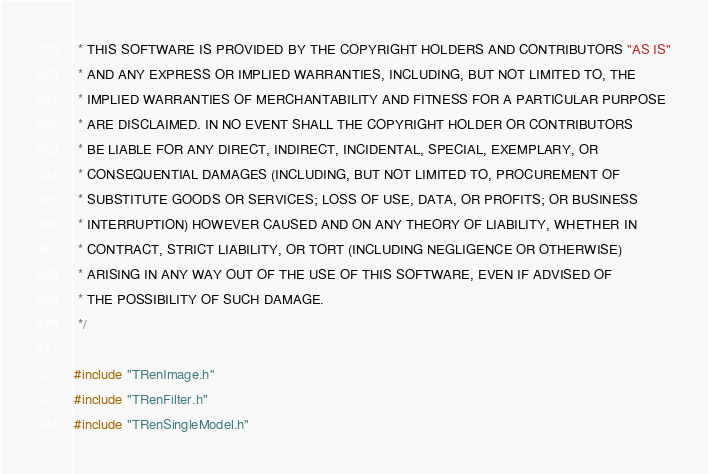<code> <loc_0><loc_0><loc_500><loc_500><_C++_> * THIS SOFTWARE IS PROVIDED BY THE COPYRIGHT HOLDERS AND CONTRIBUTORS "AS IS"
 * AND ANY EXPRESS OR IMPLIED WARRANTIES, INCLUDING, BUT NOT LIMITED TO, THE
 * IMPLIED WARRANTIES OF MERCHANTABILITY AND FITNESS FOR A PARTICULAR PURPOSE
 * ARE DISCLAIMED. IN NO EVENT SHALL THE COPYRIGHT HOLDER OR CONTRIBUTORS
 * BE LIABLE FOR ANY DIRECT, INDIRECT, INCIDENTAL, SPECIAL, EXEMPLARY, OR
 * CONSEQUENTIAL DAMAGES (INCLUDING, BUT NOT LIMITED TO, PROCUREMENT OF
 * SUBSTITUTE GOODS OR SERVICES; LOSS OF USE, DATA, OR PROFITS; OR BUSINESS
 * INTERRUPTION) HOWEVER CAUSED AND ON ANY THEORY OF LIABILITY, WHETHER IN
 * CONTRACT, STRICT LIABILITY, OR TORT (INCLUDING NEGLIGENCE OR OTHERWISE)
 * ARISING IN ANY WAY OUT OF THE USE OF THIS SOFTWARE, EVEN IF ADVISED OF
 * THE POSSIBILITY OF SUCH DAMAGE.
 */

#include "TRenImage.h"
#include "TRenFilter.h"
#include "TRenSingleModel.h"


</code> 